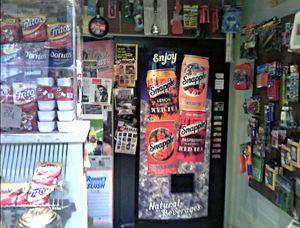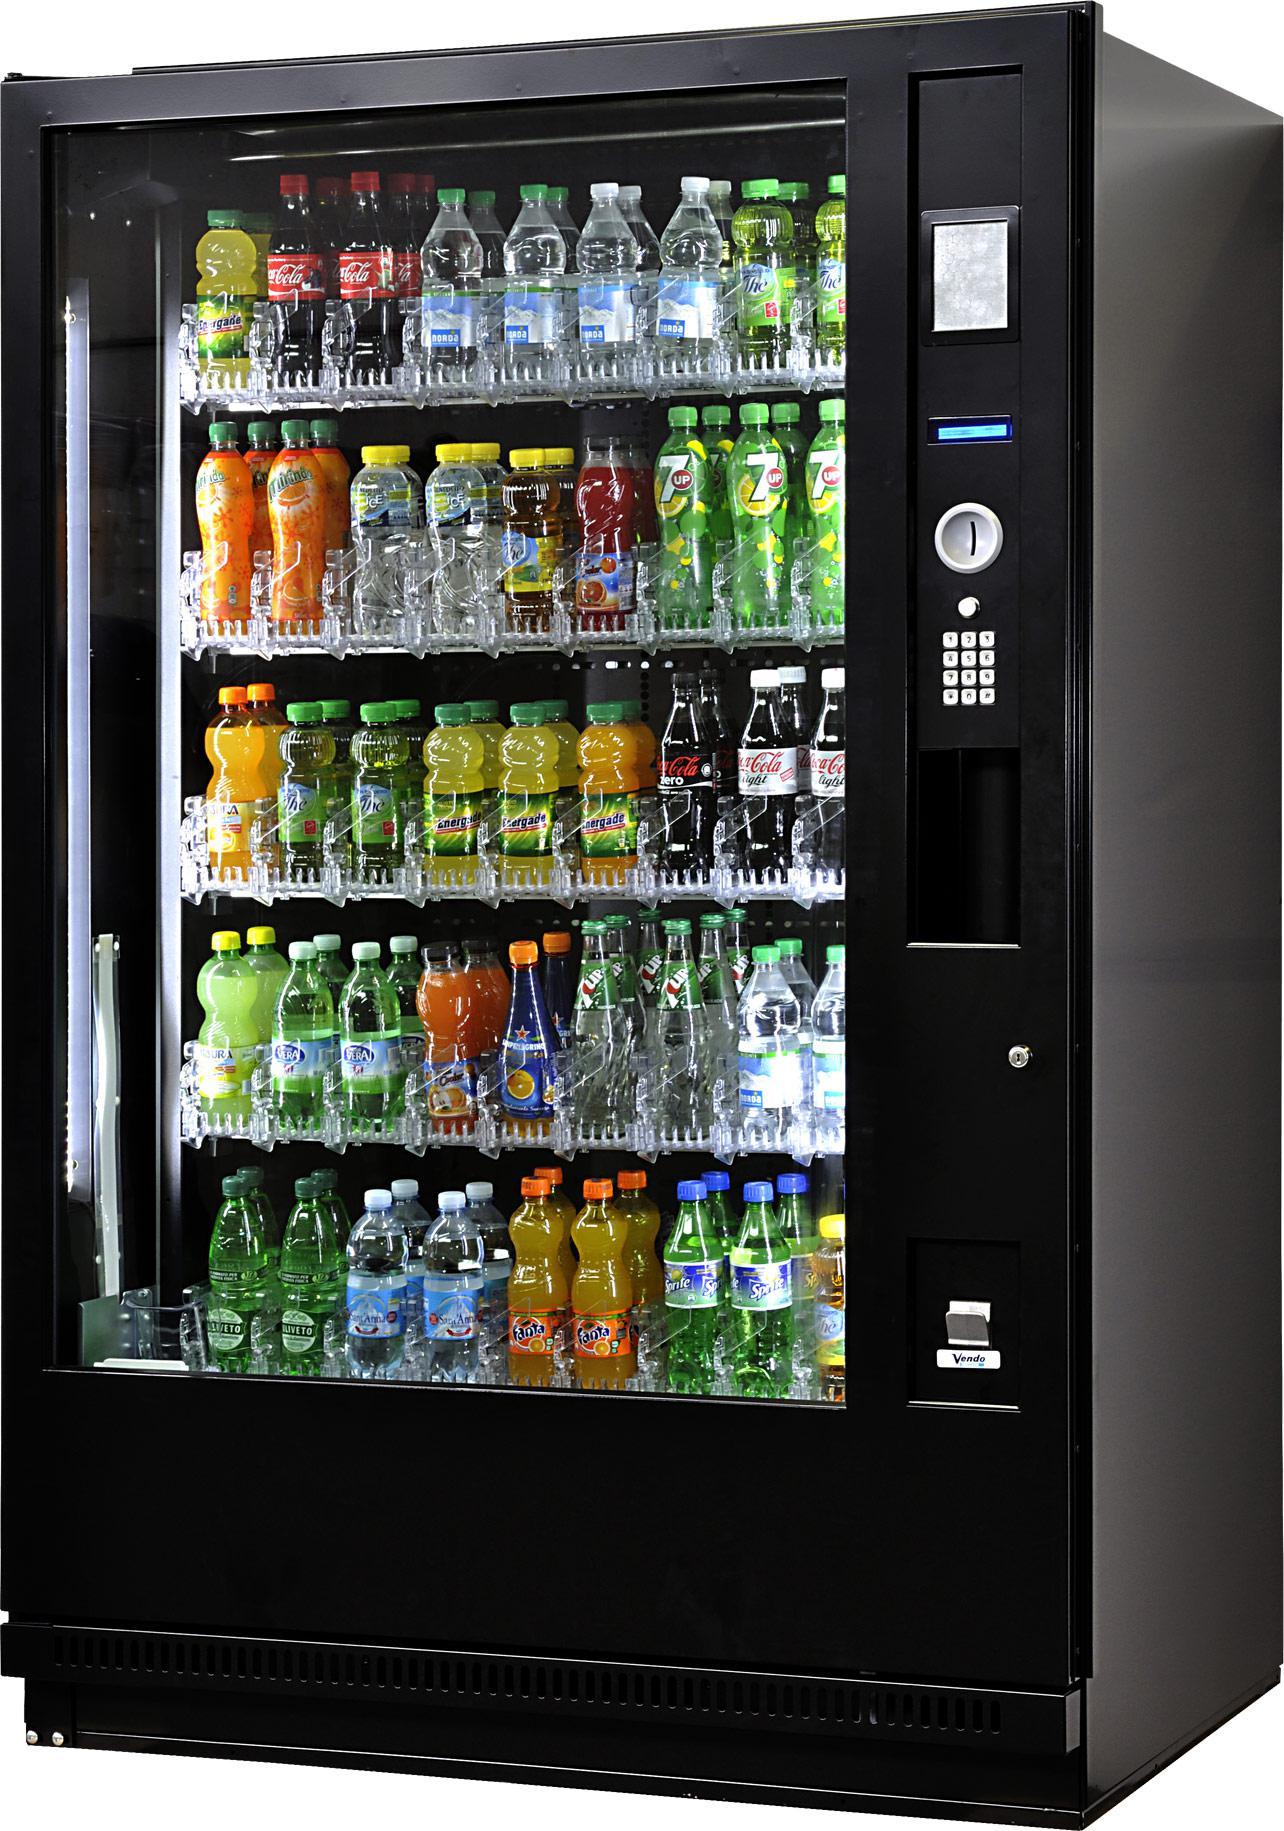The first image is the image on the left, the second image is the image on the right. Given the left and right images, does the statement "There is at least one vending machine with the Pepsi logo on it." hold true? Answer yes or no. No. The first image is the image on the left, the second image is the image on the right. Analyze the images presented: Is the assertion "In one image there is a vending machine filled with a selection bottles of various beverages for customers to choose from." valid? Answer yes or no. Yes. 